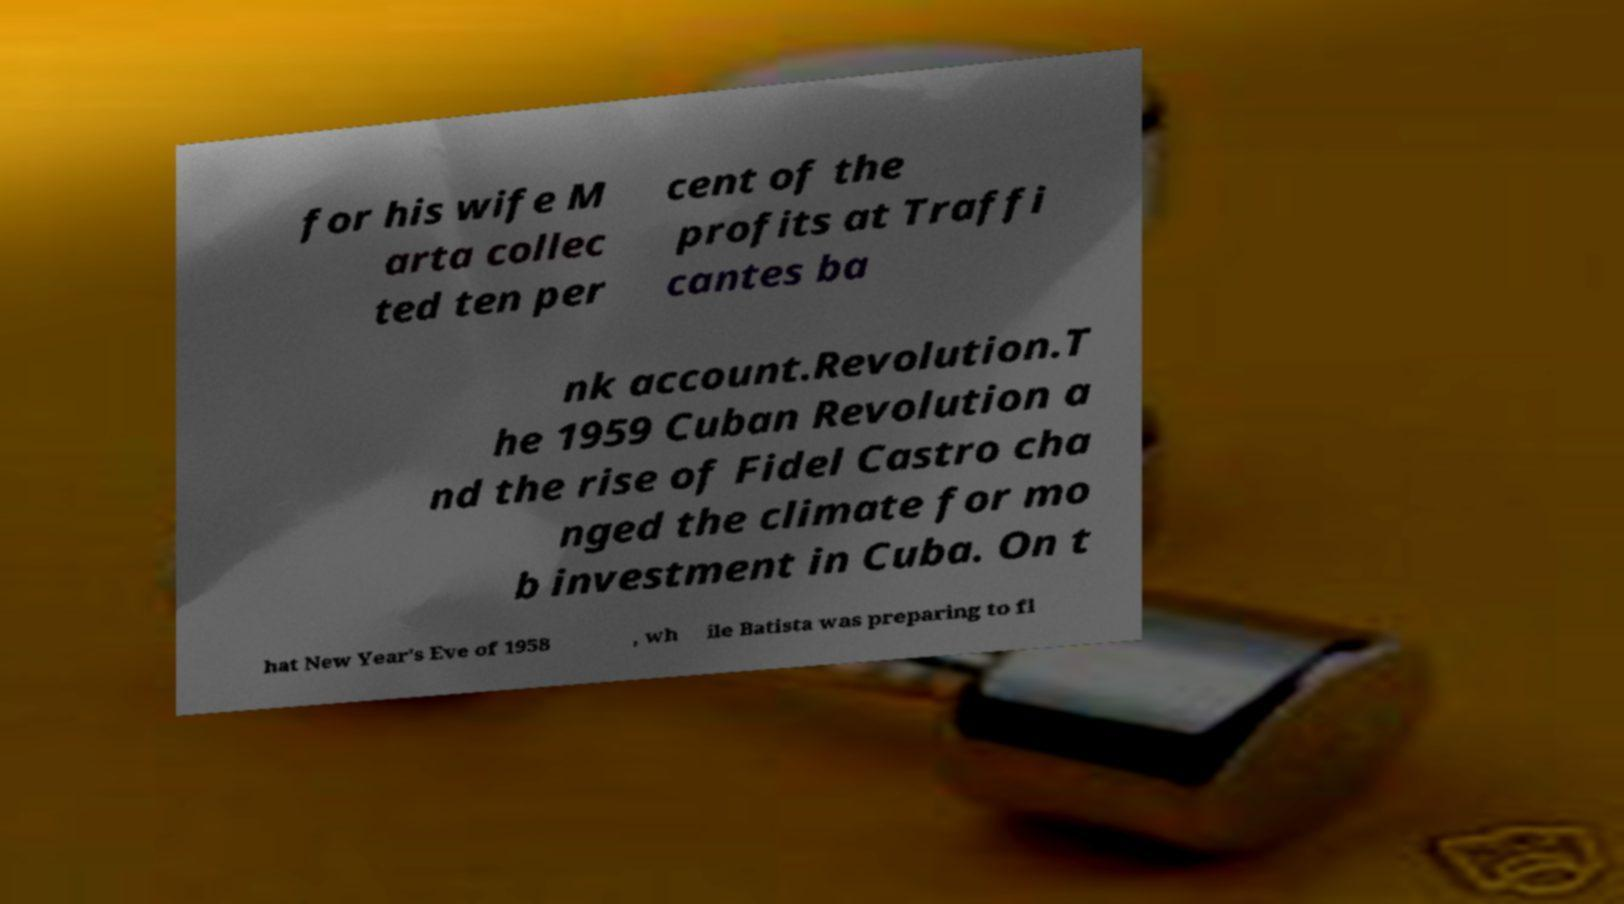Please identify and transcribe the text found in this image. for his wife M arta collec ted ten per cent of the profits at Traffi cantes ba nk account.Revolution.T he 1959 Cuban Revolution a nd the rise of Fidel Castro cha nged the climate for mo b investment in Cuba. On t hat New Year's Eve of 1958 , wh ile Batista was preparing to fl 